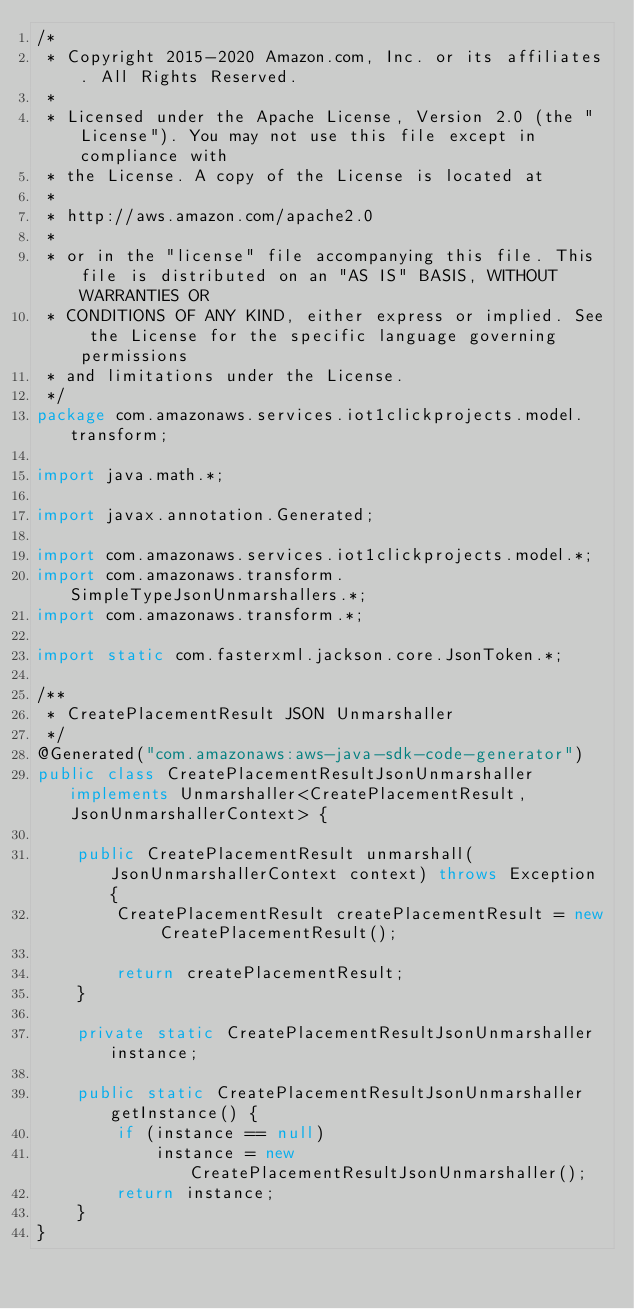Convert code to text. <code><loc_0><loc_0><loc_500><loc_500><_Java_>/*
 * Copyright 2015-2020 Amazon.com, Inc. or its affiliates. All Rights Reserved.
 * 
 * Licensed under the Apache License, Version 2.0 (the "License"). You may not use this file except in compliance with
 * the License. A copy of the License is located at
 * 
 * http://aws.amazon.com/apache2.0
 * 
 * or in the "license" file accompanying this file. This file is distributed on an "AS IS" BASIS, WITHOUT WARRANTIES OR
 * CONDITIONS OF ANY KIND, either express or implied. See the License for the specific language governing permissions
 * and limitations under the License.
 */
package com.amazonaws.services.iot1clickprojects.model.transform;

import java.math.*;

import javax.annotation.Generated;

import com.amazonaws.services.iot1clickprojects.model.*;
import com.amazonaws.transform.SimpleTypeJsonUnmarshallers.*;
import com.amazonaws.transform.*;

import static com.fasterxml.jackson.core.JsonToken.*;

/**
 * CreatePlacementResult JSON Unmarshaller
 */
@Generated("com.amazonaws:aws-java-sdk-code-generator")
public class CreatePlacementResultJsonUnmarshaller implements Unmarshaller<CreatePlacementResult, JsonUnmarshallerContext> {

    public CreatePlacementResult unmarshall(JsonUnmarshallerContext context) throws Exception {
        CreatePlacementResult createPlacementResult = new CreatePlacementResult();

        return createPlacementResult;
    }

    private static CreatePlacementResultJsonUnmarshaller instance;

    public static CreatePlacementResultJsonUnmarshaller getInstance() {
        if (instance == null)
            instance = new CreatePlacementResultJsonUnmarshaller();
        return instance;
    }
}
</code> 